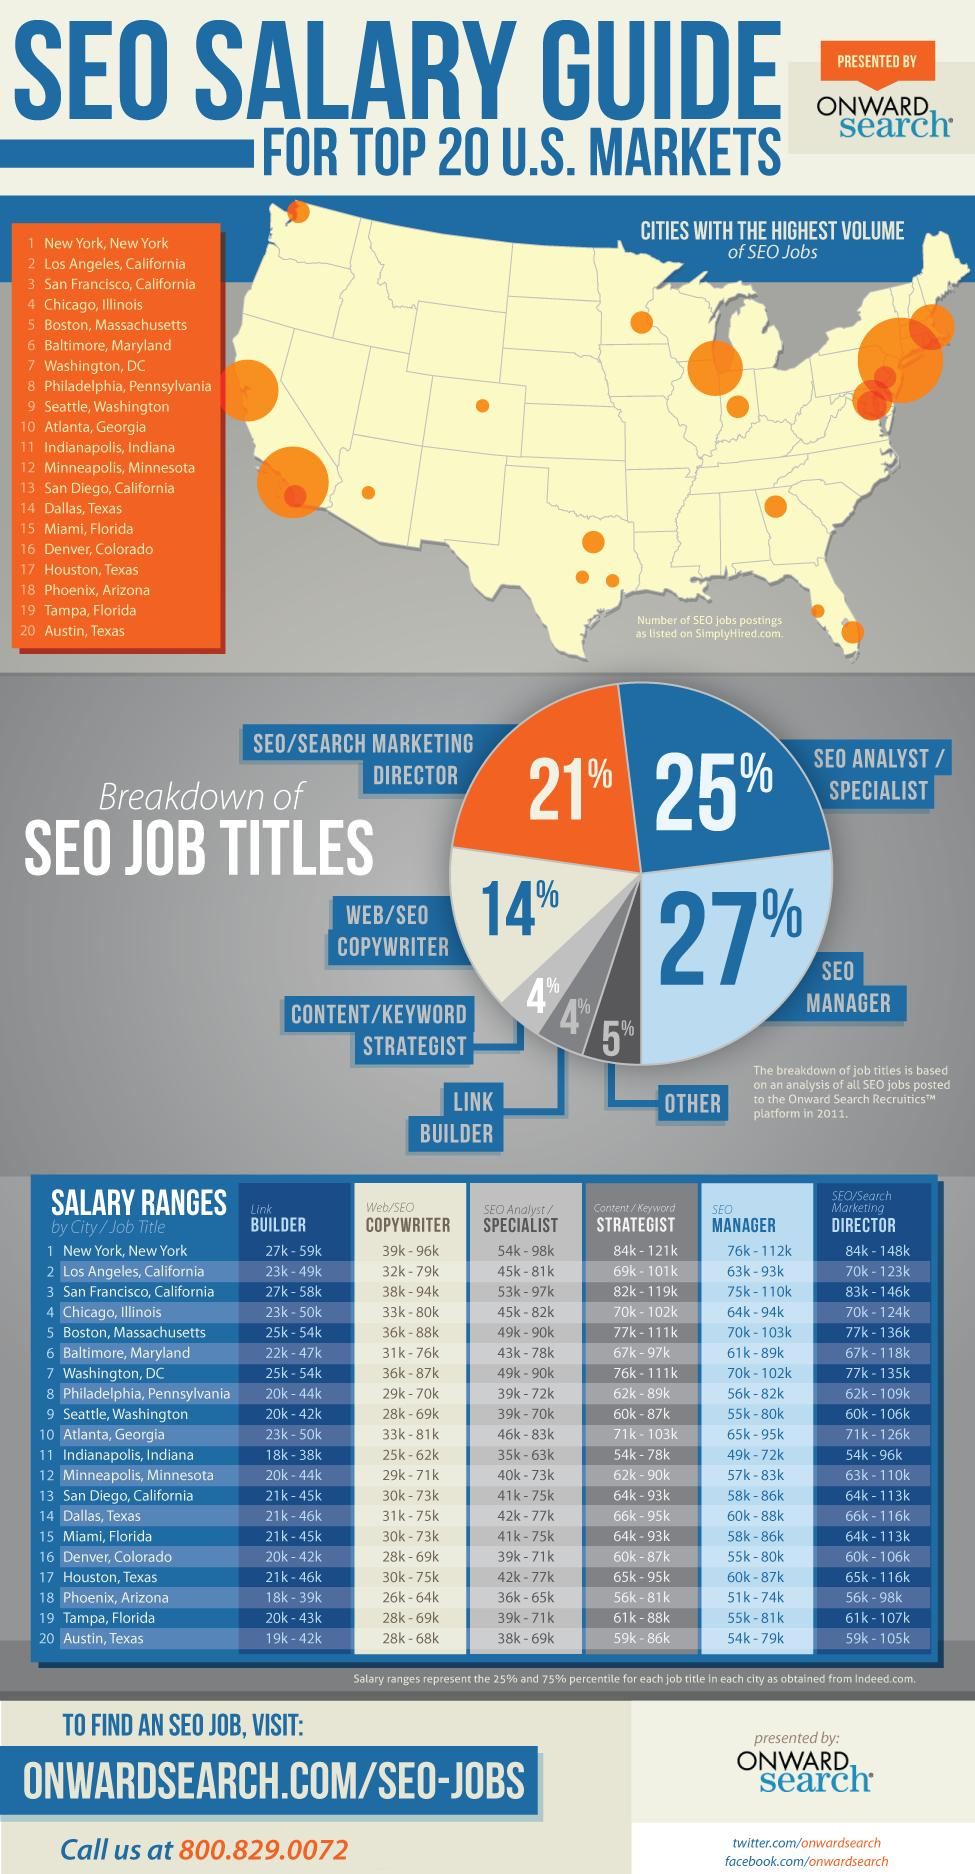Specify some key components in this picture. According to a recent study, only 4% of people work as content strategists or link builders. There are a total of 7 items listed in the table. The salary range for link builders in Seattle and Denver is between 20,000 and 42,000 USD. The role of Strategist appears to be the least paid category in the state of Indianapolis, Indiana. Atlanta, Georgia is the place that pays the fourth highest salary range for Directors. 